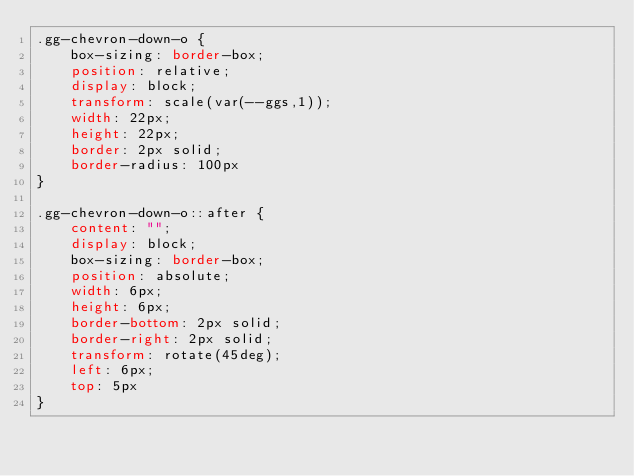<code> <loc_0><loc_0><loc_500><loc_500><_CSS_>.gg-chevron-down-o {
    box-sizing: border-box;
    position: relative;
    display: block;
    transform: scale(var(--ggs,1));
    width: 22px;
    height: 22px;
    border: 2px solid;
    border-radius: 100px
}

.gg-chevron-down-o::after {
    content: "";
    display: block;
    box-sizing: border-box;
    position: absolute;
    width: 6px;
    height: 6px;
    border-bottom: 2px solid;
    border-right: 2px solid;
    transform: rotate(45deg);
    left: 6px;
    top: 5px
}</code> 